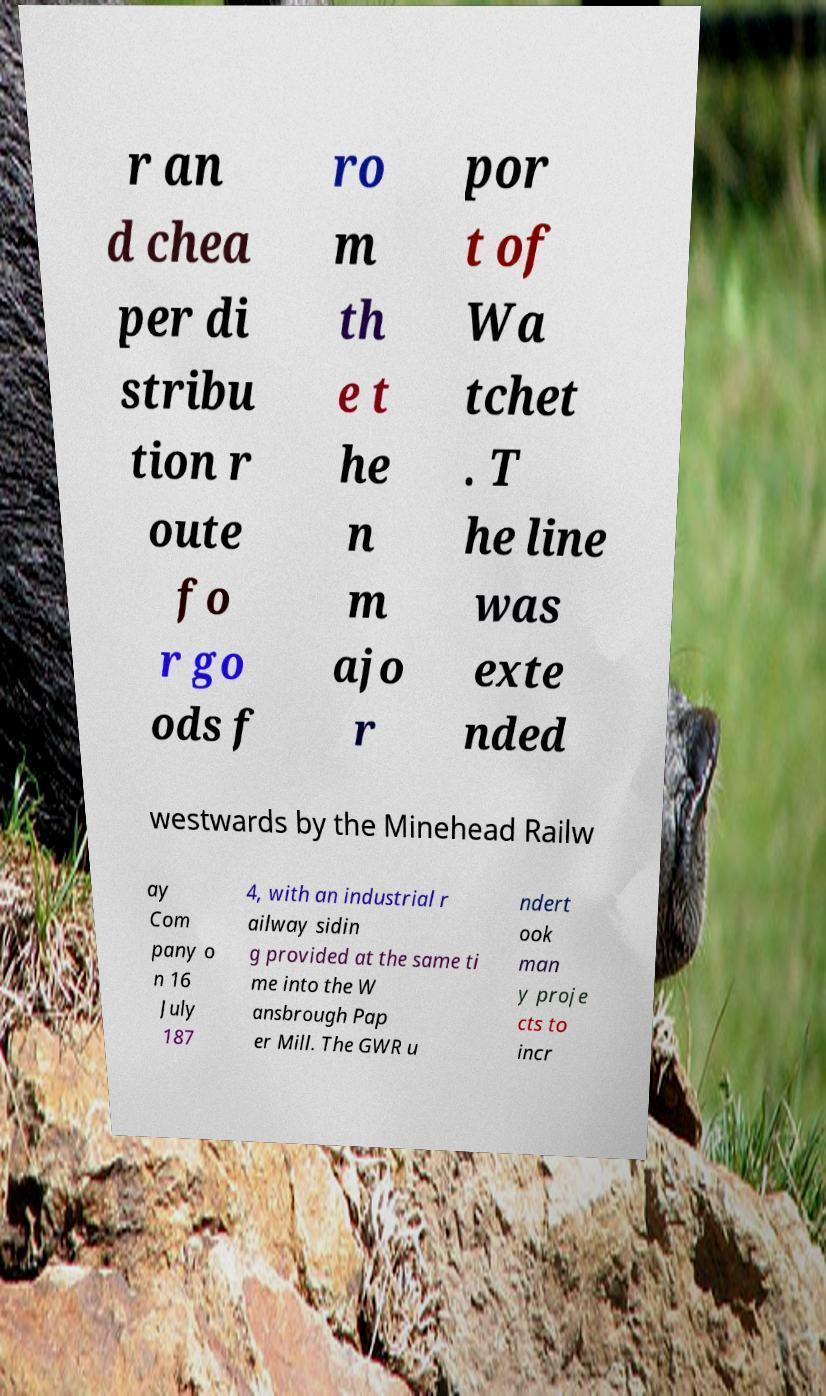I need the written content from this picture converted into text. Can you do that? r an d chea per di stribu tion r oute fo r go ods f ro m th e t he n m ajo r por t of Wa tchet . T he line was exte nded westwards by the Minehead Railw ay Com pany o n 16 July 187 4, with an industrial r ailway sidin g provided at the same ti me into the W ansbrough Pap er Mill. The GWR u ndert ook man y proje cts to incr 